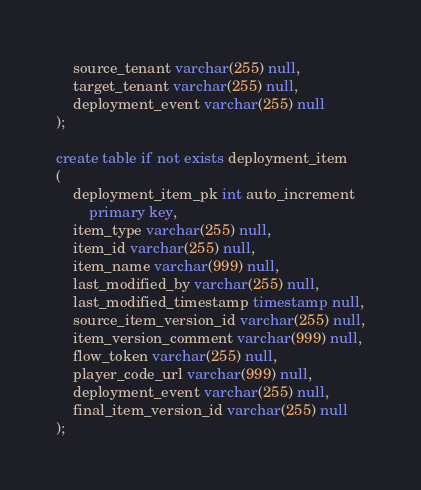Convert code to text. <code><loc_0><loc_0><loc_500><loc_500><_SQL_>	source_tenant varchar(255) null,
	target_tenant varchar(255) null,
	deployment_event varchar(255) null
);

create table if not exists deployment_item
(
	deployment_item_pk int auto_increment
		primary key,
	item_type varchar(255) null,
	item_id varchar(255) null,
	item_name varchar(999) null,
	last_modified_by varchar(255) null,
	last_modified_timestamp timestamp null,
	source_item_version_id varchar(255) null,
	item_version_comment varchar(999) null,
	flow_token varchar(255) null,
	player_code_url varchar(999) null,
	deployment_event varchar(255) null,
	final_item_version_id varchar(255) null
);

</code> 